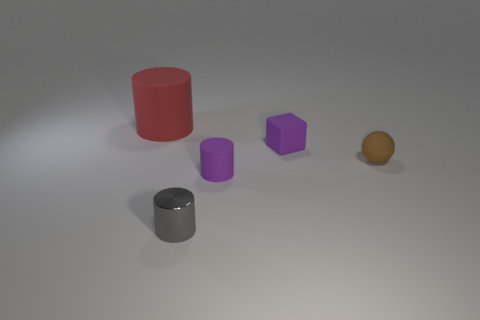Is there a small brown thing that is behind the tiny matte thing that is right of the tiny matte thing behind the tiny brown thing?
Offer a terse response. No. The red matte object that is the same shape as the small gray object is what size?
Give a very brief answer. Large. Is there any other thing that is made of the same material as the large red thing?
Offer a terse response. Yes. Is there a gray block?
Keep it short and to the point. No. Is the color of the big object the same as the small matte thing behind the brown rubber ball?
Your answer should be very brief. No. There is a purple thing in front of the brown rubber object behind the purple rubber object that is in front of the brown matte sphere; what size is it?
Provide a short and direct response. Small. What number of other tiny rubber cubes have the same color as the rubber cube?
Your response must be concise. 0. What number of things are small yellow metallic spheres or small purple objects that are in front of the tiny brown matte sphere?
Ensure brevity in your answer.  1. The big matte object has what color?
Provide a succinct answer. Red. There is a matte cylinder behind the tiny rubber cylinder; what is its color?
Ensure brevity in your answer.  Red. 